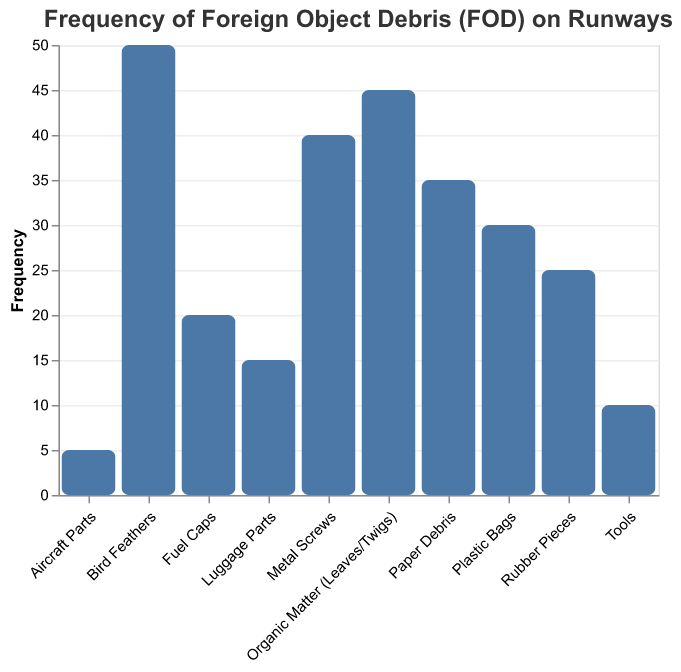What's the title of the figure? The title of the figure is displayed at the top and describes the content of the visualization. It reads "Frequency of Foreign Object Debris (FOD) on Runways."
Answer: Frequency of Foreign Object Debris (FOD) on Runways What are the categories with the highest and lowest frequencies? By inspecting the height of the bars, the category with the highest frequency is "Bird Feathers" (50), and the lowest is "Aircraft Parts" (5).
Answer: Bird Feathers and Aircraft Parts How many categories have a frequency greater than 30? To find this, count the number of bars with a frequency higher than 30. These categories are "Bird Feathers" (50), "Metal Screws" (40), "Organic Matter (Leaves/Twigs)" (45), and "Paper Debris" (35). This gives us 4 categories.
Answer: 4 What is the total frequency of all foreign object debris combined? Sum the frequency values for all categories: 50 + 30 + 40 + 25 + 35 + 45 + 15 + 20 + 10 + 5 = 275.
Answer: 275 Which categories have less than 20 in frequency? Identify bars shorter than the 20 mark, which are "Luggage Parts" (15), "Tools" (10), and "Aircraft Parts" (5).
Answer: Luggage Parts, Tools, and Aircraft Parts Is the frequency of "Organic Matter" greater than the frequency of "Plastic Bags"? Compare the heights of the bars for these categories. "Organic Matter (Leaves/Twigs)" has a frequency of 45, while "Plastic Bags" has a frequency of 30. 45 is indeed greater than 30.
Answer: Yes What is the average frequency of the debris types shown? Sum the frequencies (275) and divide by the number of categories (10): 275 / 10 = 27.5.
Answer: 27.5 What is the difference in frequency between "Metal Screws" and "Rubber Pieces"? Subtract the frequency of "Rubber Pieces" (25) from "Metal Screws" (40): 40 - 25 = 15.
Answer: 15 Sort the categories by frequency in ascending order. List categories from lowest to highest frequencies: "Aircraft Parts" (5), "Tools" (10), "Luggage Parts" (15), "Fuel Caps" (20), "Rubber Pieces" (25), "Plastic Bags" (30), "Paper Debris" (35), "Metal Screws" (40), "Organic Matter (Leaves/Twigs)" (45), "Bird Feathers" (50).
Answer: Aircraft Parts, Tools, Luggage Parts, Fuel Caps, Rubber Pieces, Plastic Bags, Paper Debris, Metal Screws, Organic Matter (Leaves/Twigs), Bird Feathers What percentage of the total debris is made up of "Bird Feathers"? Calculate the percentage by dividing the frequency of "Bird Feathers" (50) by total frequency (275) and multiply by 100: (50 / 275) * 100 = approximately 18.18%.
Answer: 18.18% 